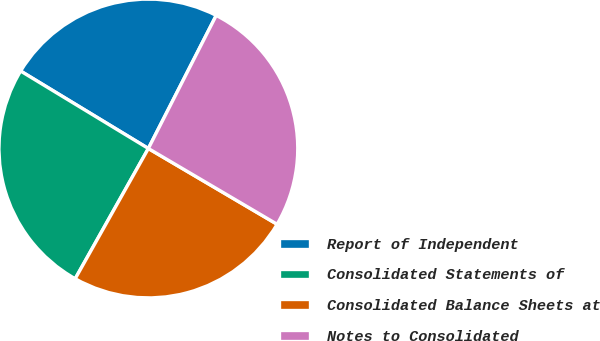Convert chart. <chart><loc_0><loc_0><loc_500><loc_500><pie_chart><fcel>Report of Independent<fcel>Consolidated Statements of<fcel>Consolidated Balance Sheets at<fcel>Notes to Consolidated<nl><fcel>23.83%<fcel>25.53%<fcel>24.68%<fcel>25.96%<nl></chart> 